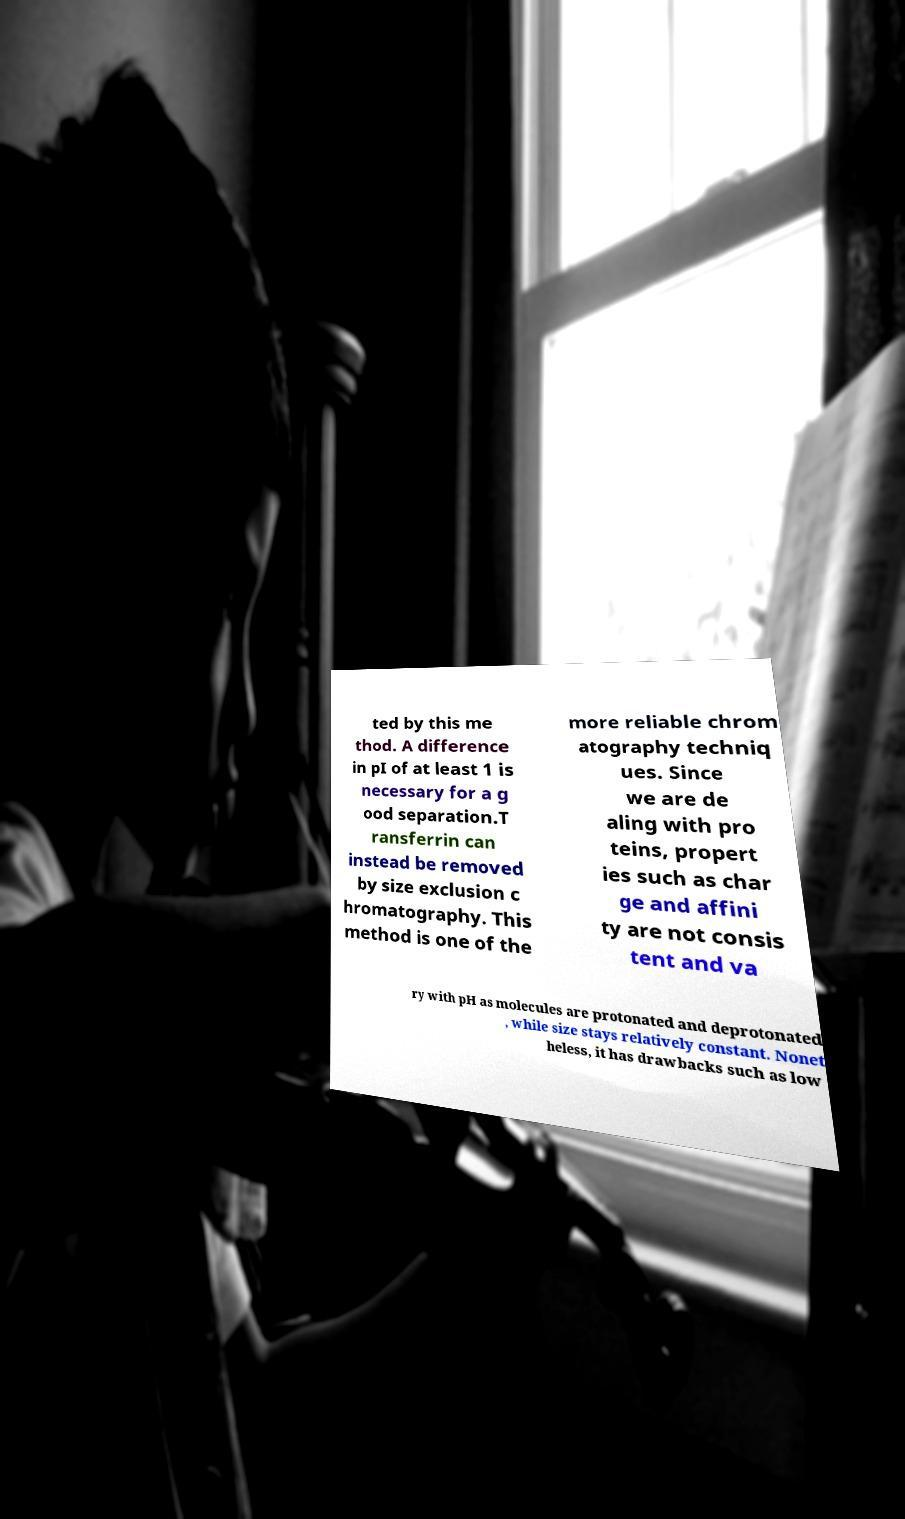Please read and relay the text visible in this image. What does it say? ted by this me thod. A difference in pI of at least 1 is necessary for a g ood separation.T ransferrin can instead be removed by size exclusion c hromatography. This method is one of the more reliable chrom atography techniq ues. Since we are de aling with pro teins, propert ies such as char ge and affini ty are not consis tent and va ry with pH as molecules are protonated and deprotonated , while size stays relatively constant. Nonet heless, it has drawbacks such as low 